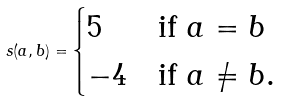Convert formula to latex. <formula><loc_0><loc_0><loc_500><loc_500>s ( a , b ) = \begin{cases} 5 & \text {if $a=b$} \\ - 4 & \text {if $a\neq b$} . \\ \end{cases}</formula> 